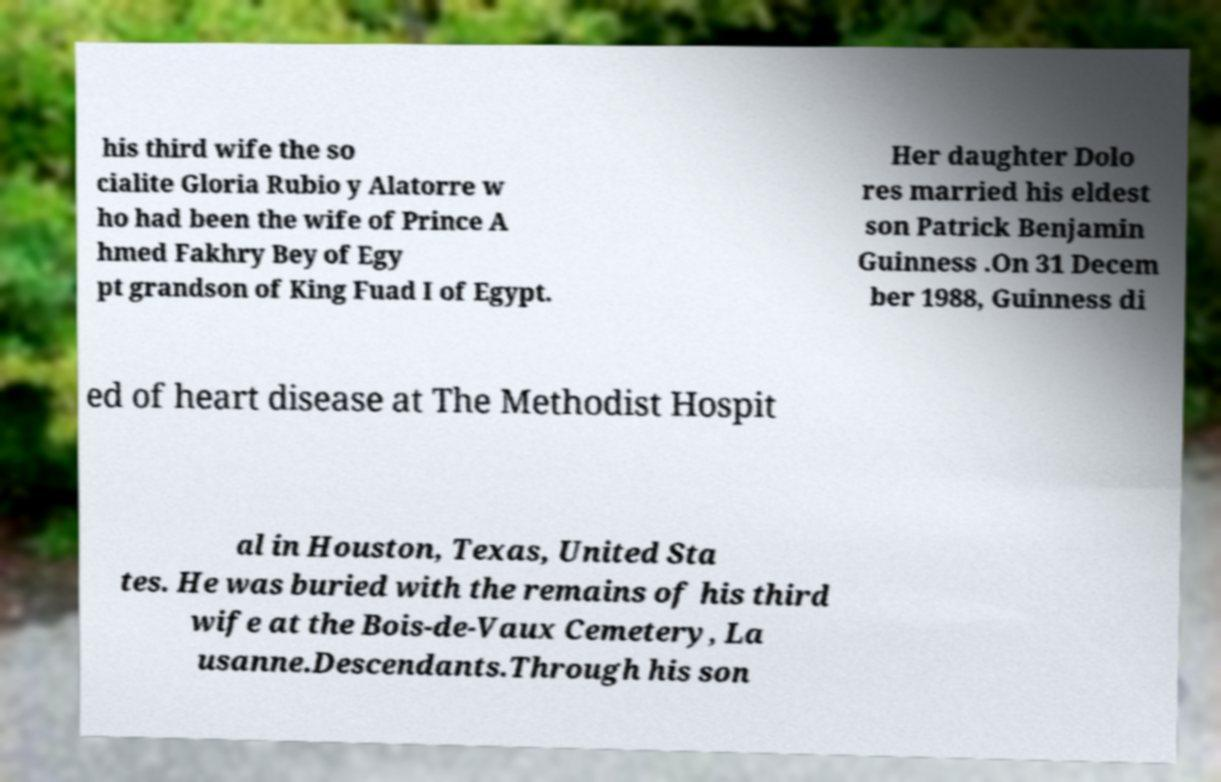I need the written content from this picture converted into text. Can you do that? his third wife the so cialite Gloria Rubio y Alatorre w ho had been the wife of Prince A hmed Fakhry Bey of Egy pt grandson of King Fuad I of Egypt. Her daughter Dolo res married his eldest son Patrick Benjamin Guinness .On 31 Decem ber 1988, Guinness di ed of heart disease at The Methodist Hospit al in Houston, Texas, United Sta tes. He was buried with the remains of his third wife at the Bois-de-Vaux Cemetery, La usanne.Descendants.Through his son 